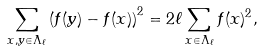<formula> <loc_0><loc_0><loc_500><loc_500>\sum _ { x , y \in \Lambda _ { \ell } } \left ( f ( y ) - f ( x ) \right ) ^ { 2 } = 2 \ell \sum _ { x \in \Lambda _ { \ell } } f ( x ) ^ { 2 } ,</formula> 